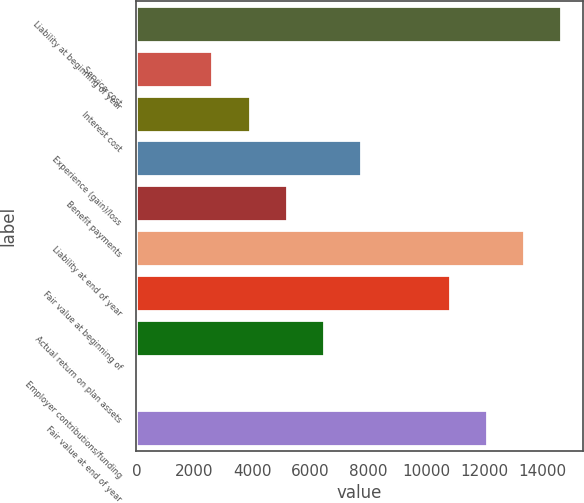Convert chart. <chart><loc_0><loc_0><loc_500><loc_500><bar_chart><fcel>Liability at beginning of year<fcel>Service cost<fcel>Interest cost<fcel>Experience (gain)/loss<fcel>Benefit payments<fcel>Liability at end of year<fcel>Fair value at beginning of<fcel>Actual return on plan assets<fcel>Employer contributions/funding<fcel>Fair value at end of year<nl><fcel>14663.9<fcel>2627.6<fcel>3909.9<fcel>7756.8<fcel>5192.2<fcel>13381.6<fcel>10817<fcel>6474.5<fcel>63<fcel>12099.3<nl></chart> 